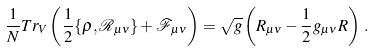Convert formula to latex. <formula><loc_0><loc_0><loc_500><loc_500>\frac { 1 } { N } T r _ { V } \left ( \frac { 1 } { 2 } \{ \rho , \mathcal { R } _ { \mu \nu } \} + \mathcal { F } _ { \mu \nu } \right ) = \sqrt { g } \left ( R _ { \mu \nu } - \frac { 1 } { 2 } g _ { \mu \nu } R \right ) \, .</formula> 